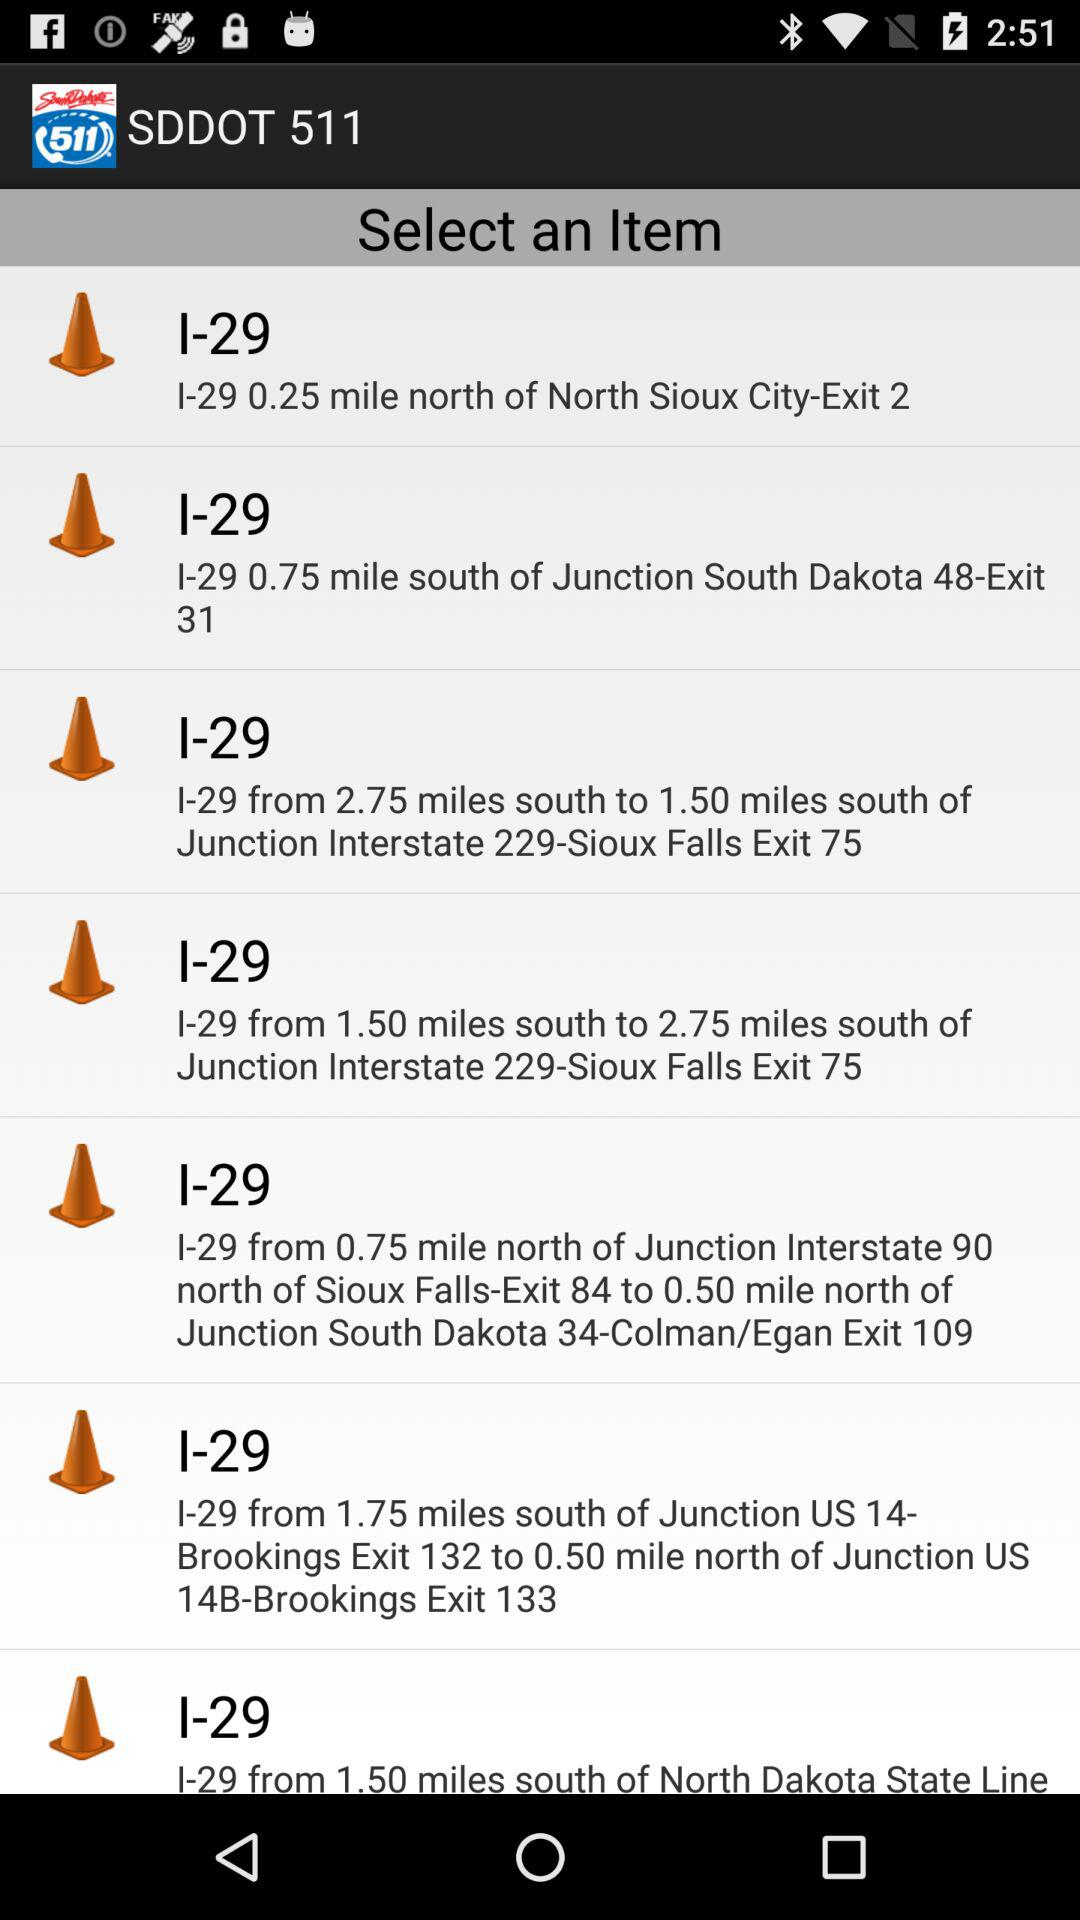I-29 is how many miles from north of North Sioux city-Exit 2? I-29 is 0.25 miles from north of North Sioux city-Exit 2. 